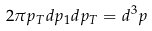<formula> <loc_0><loc_0><loc_500><loc_500>2 \pi p _ { T } d p _ { 1 } d p _ { T } = d ^ { 3 } p</formula> 